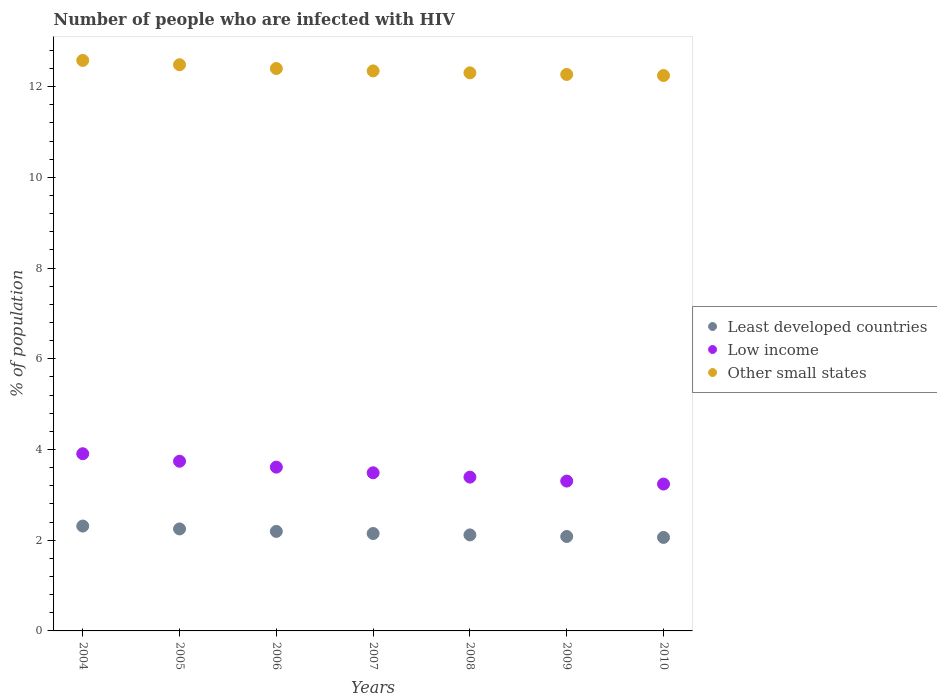How many different coloured dotlines are there?
Provide a succinct answer. 3. Is the number of dotlines equal to the number of legend labels?
Give a very brief answer. Yes. What is the percentage of HIV infected population in in Low income in 2008?
Your answer should be very brief. 3.39. Across all years, what is the maximum percentage of HIV infected population in in Other small states?
Provide a short and direct response. 12.58. Across all years, what is the minimum percentage of HIV infected population in in Other small states?
Offer a terse response. 12.24. In which year was the percentage of HIV infected population in in Least developed countries maximum?
Your answer should be compact. 2004. In which year was the percentage of HIV infected population in in Least developed countries minimum?
Provide a succinct answer. 2010. What is the total percentage of HIV infected population in in Low income in the graph?
Provide a succinct answer. 24.68. What is the difference between the percentage of HIV infected population in in Least developed countries in 2004 and that in 2008?
Offer a terse response. 0.2. What is the difference between the percentage of HIV infected population in in Other small states in 2005 and the percentage of HIV infected population in in Low income in 2010?
Your answer should be very brief. 9.24. What is the average percentage of HIV infected population in in Low income per year?
Your response must be concise. 3.53. In the year 2009, what is the difference between the percentage of HIV infected population in in Low income and percentage of HIV infected population in in Other small states?
Provide a succinct answer. -8.96. In how many years, is the percentage of HIV infected population in in Least developed countries greater than 2.4 %?
Ensure brevity in your answer.  0. What is the ratio of the percentage of HIV infected population in in Least developed countries in 2004 to that in 2009?
Offer a very short reply. 1.11. Is the percentage of HIV infected population in in Other small states in 2005 less than that in 2006?
Offer a very short reply. No. What is the difference between the highest and the second highest percentage of HIV infected population in in Least developed countries?
Offer a terse response. 0.06. What is the difference between the highest and the lowest percentage of HIV infected population in in Other small states?
Your response must be concise. 0.33. Does the percentage of HIV infected population in in Low income monotonically increase over the years?
Your answer should be very brief. No. Is the percentage of HIV infected population in in Other small states strictly less than the percentage of HIV infected population in in Least developed countries over the years?
Ensure brevity in your answer.  No. How many years are there in the graph?
Your answer should be very brief. 7. What is the difference between two consecutive major ticks on the Y-axis?
Your answer should be compact. 2. Are the values on the major ticks of Y-axis written in scientific E-notation?
Ensure brevity in your answer.  No. Where does the legend appear in the graph?
Keep it short and to the point. Center right. How many legend labels are there?
Provide a short and direct response. 3. What is the title of the graph?
Offer a terse response. Number of people who are infected with HIV. Does "Cote d'Ivoire" appear as one of the legend labels in the graph?
Your answer should be compact. No. What is the label or title of the X-axis?
Provide a succinct answer. Years. What is the label or title of the Y-axis?
Ensure brevity in your answer.  % of population. What is the % of population of Least developed countries in 2004?
Offer a very short reply. 2.31. What is the % of population of Low income in 2004?
Give a very brief answer. 3.91. What is the % of population of Other small states in 2004?
Your response must be concise. 12.58. What is the % of population in Least developed countries in 2005?
Your answer should be compact. 2.25. What is the % of population of Low income in 2005?
Your answer should be compact. 3.74. What is the % of population in Other small states in 2005?
Your answer should be very brief. 12.48. What is the % of population of Least developed countries in 2006?
Keep it short and to the point. 2.19. What is the % of population in Low income in 2006?
Your answer should be compact. 3.61. What is the % of population in Other small states in 2006?
Provide a succinct answer. 12.4. What is the % of population in Least developed countries in 2007?
Offer a terse response. 2.15. What is the % of population in Low income in 2007?
Keep it short and to the point. 3.49. What is the % of population of Other small states in 2007?
Provide a short and direct response. 12.35. What is the % of population of Least developed countries in 2008?
Your answer should be compact. 2.12. What is the % of population of Low income in 2008?
Provide a short and direct response. 3.39. What is the % of population in Other small states in 2008?
Your response must be concise. 12.3. What is the % of population in Least developed countries in 2009?
Provide a short and direct response. 2.08. What is the % of population of Low income in 2009?
Make the answer very short. 3.3. What is the % of population in Other small states in 2009?
Offer a very short reply. 12.27. What is the % of population in Least developed countries in 2010?
Provide a short and direct response. 2.06. What is the % of population of Low income in 2010?
Ensure brevity in your answer.  3.24. What is the % of population in Other small states in 2010?
Provide a succinct answer. 12.24. Across all years, what is the maximum % of population in Least developed countries?
Your answer should be very brief. 2.31. Across all years, what is the maximum % of population in Low income?
Your response must be concise. 3.91. Across all years, what is the maximum % of population of Other small states?
Offer a very short reply. 12.58. Across all years, what is the minimum % of population in Least developed countries?
Offer a very short reply. 2.06. Across all years, what is the minimum % of population in Low income?
Your answer should be very brief. 3.24. Across all years, what is the minimum % of population of Other small states?
Ensure brevity in your answer.  12.24. What is the total % of population of Least developed countries in the graph?
Your answer should be compact. 15.16. What is the total % of population in Low income in the graph?
Give a very brief answer. 24.68. What is the total % of population of Other small states in the graph?
Provide a succinct answer. 86.62. What is the difference between the % of population of Least developed countries in 2004 and that in 2005?
Give a very brief answer. 0.06. What is the difference between the % of population in Low income in 2004 and that in 2005?
Offer a very short reply. 0.17. What is the difference between the % of population of Other small states in 2004 and that in 2005?
Offer a terse response. 0.09. What is the difference between the % of population in Least developed countries in 2004 and that in 2006?
Provide a short and direct response. 0.12. What is the difference between the % of population of Low income in 2004 and that in 2006?
Give a very brief answer. 0.3. What is the difference between the % of population of Other small states in 2004 and that in 2006?
Provide a succinct answer. 0.18. What is the difference between the % of population in Least developed countries in 2004 and that in 2007?
Offer a very short reply. 0.16. What is the difference between the % of population of Low income in 2004 and that in 2007?
Your answer should be compact. 0.42. What is the difference between the % of population of Other small states in 2004 and that in 2007?
Provide a succinct answer. 0.23. What is the difference between the % of population in Least developed countries in 2004 and that in 2008?
Make the answer very short. 0.2. What is the difference between the % of population in Low income in 2004 and that in 2008?
Your answer should be very brief. 0.52. What is the difference between the % of population of Other small states in 2004 and that in 2008?
Offer a very short reply. 0.27. What is the difference between the % of population of Least developed countries in 2004 and that in 2009?
Ensure brevity in your answer.  0.23. What is the difference between the % of population of Low income in 2004 and that in 2009?
Provide a succinct answer. 0.6. What is the difference between the % of population of Other small states in 2004 and that in 2009?
Ensure brevity in your answer.  0.31. What is the difference between the % of population in Least developed countries in 2004 and that in 2010?
Ensure brevity in your answer.  0.25. What is the difference between the % of population in Low income in 2004 and that in 2010?
Offer a terse response. 0.67. What is the difference between the % of population of Other small states in 2004 and that in 2010?
Keep it short and to the point. 0.33. What is the difference between the % of population in Least developed countries in 2005 and that in 2006?
Provide a succinct answer. 0.05. What is the difference between the % of population in Low income in 2005 and that in 2006?
Your answer should be compact. 0.13. What is the difference between the % of population in Other small states in 2005 and that in 2006?
Your answer should be very brief. 0.08. What is the difference between the % of population of Least developed countries in 2005 and that in 2007?
Your response must be concise. 0.1. What is the difference between the % of population of Low income in 2005 and that in 2007?
Keep it short and to the point. 0.25. What is the difference between the % of population of Other small states in 2005 and that in 2007?
Offer a terse response. 0.14. What is the difference between the % of population in Least developed countries in 2005 and that in 2008?
Your response must be concise. 0.13. What is the difference between the % of population in Other small states in 2005 and that in 2008?
Provide a succinct answer. 0.18. What is the difference between the % of population of Least developed countries in 2005 and that in 2009?
Your answer should be compact. 0.17. What is the difference between the % of population in Low income in 2005 and that in 2009?
Your answer should be very brief. 0.44. What is the difference between the % of population in Other small states in 2005 and that in 2009?
Make the answer very short. 0.21. What is the difference between the % of population in Least developed countries in 2005 and that in 2010?
Ensure brevity in your answer.  0.19. What is the difference between the % of population of Low income in 2005 and that in 2010?
Your response must be concise. 0.5. What is the difference between the % of population of Other small states in 2005 and that in 2010?
Your response must be concise. 0.24. What is the difference between the % of population of Least developed countries in 2006 and that in 2007?
Ensure brevity in your answer.  0.05. What is the difference between the % of population of Low income in 2006 and that in 2007?
Your answer should be very brief. 0.12. What is the difference between the % of population in Other small states in 2006 and that in 2007?
Give a very brief answer. 0.05. What is the difference between the % of population in Least developed countries in 2006 and that in 2008?
Provide a short and direct response. 0.08. What is the difference between the % of population in Low income in 2006 and that in 2008?
Keep it short and to the point. 0.22. What is the difference between the % of population of Other small states in 2006 and that in 2008?
Your answer should be compact. 0.09. What is the difference between the % of population in Least developed countries in 2006 and that in 2009?
Provide a succinct answer. 0.11. What is the difference between the % of population in Low income in 2006 and that in 2009?
Offer a very short reply. 0.31. What is the difference between the % of population of Other small states in 2006 and that in 2009?
Provide a short and direct response. 0.13. What is the difference between the % of population of Least developed countries in 2006 and that in 2010?
Give a very brief answer. 0.13. What is the difference between the % of population in Low income in 2006 and that in 2010?
Your response must be concise. 0.37. What is the difference between the % of population in Other small states in 2006 and that in 2010?
Keep it short and to the point. 0.15. What is the difference between the % of population in Least developed countries in 2007 and that in 2008?
Offer a very short reply. 0.03. What is the difference between the % of population in Low income in 2007 and that in 2008?
Ensure brevity in your answer.  0.1. What is the difference between the % of population in Other small states in 2007 and that in 2008?
Make the answer very short. 0.04. What is the difference between the % of population of Least developed countries in 2007 and that in 2009?
Keep it short and to the point. 0.07. What is the difference between the % of population in Low income in 2007 and that in 2009?
Give a very brief answer. 0.18. What is the difference between the % of population of Other small states in 2007 and that in 2009?
Ensure brevity in your answer.  0.08. What is the difference between the % of population of Least developed countries in 2007 and that in 2010?
Give a very brief answer. 0.09. What is the difference between the % of population in Low income in 2007 and that in 2010?
Give a very brief answer. 0.25. What is the difference between the % of population of Other small states in 2007 and that in 2010?
Ensure brevity in your answer.  0.1. What is the difference between the % of population in Least developed countries in 2008 and that in 2009?
Your response must be concise. 0.03. What is the difference between the % of population in Low income in 2008 and that in 2009?
Provide a short and direct response. 0.09. What is the difference between the % of population in Other small states in 2008 and that in 2009?
Your response must be concise. 0.04. What is the difference between the % of population in Least developed countries in 2008 and that in 2010?
Your answer should be compact. 0.06. What is the difference between the % of population of Low income in 2008 and that in 2010?
Ensure brevity in your answer.  0.15. What is the difference between the % of population in Other small states in 2008 and that in 2010?
Keep it short and to the point. 0.06. What is the difference between the % of population in Least developed countries in 2009 and that in 2010?
Offer a terse response. 0.02. What is the difference between the % of population of Low income in 2009 and that in 2010?
Offer a very short reply. 0.07. What is the difference between the % of population of Other small states in 2009 and that in 2010?
Provide a succinct answer. 0.02. What is the difference between the % of population in Least developed countries in 2004 and the % of population in Low income in 2005?
Your answer should be very brief. -1.43. What is the difference between the % of population of Least developed countries in 2004 and the % of population of Other small states in 2005?
Provide a succinct answer. -10.17. What is the difference between the % of population in Low income in 2004 and the % of population in Other small states in 2005?
Make the answer very short. -8.58. What is the difference between the % of population of Least developed countries in 2004 and the % of population of Low income in 2006?
Make the answer very short. -1.3. What is the difference between the % of population in Least developed countries in 2004 and the % of population in Other small states in 2006?
Ensure brevity in your answer.  -10.09. What is the difference between the % of population in Low income in 2004 and the % of population in Other small states in 2006?
Ensure brevity in your answer.  -8.49. What is the difference between the % of population of Least developed countries in 2004 and the % of population of Low income in 2007?
Provide a succinct answer. -1.17. What is the difference between the % of population of Least developed countries in 2004 and the % of population of Other small states in 2007?
Provide a succinct answer. -10.03. What is the difference between the % of population of Low income in 2004 and the % of population of Other small states in 2007?
Keep it short and to the point. -8.44. What is the difference between the % of population of Least developed countries in 2004 and the % of population of Low income in 2008?
Make the answer very short. -1.08. What is the difference between the % of population of Least developed countries in 2004 and the % of population of Other small states in 2008?
Keep it short and to the point. -9.99. What is the difference between the % of population of Low income in 2004 and the % of population of Other small states in 2008?
Your response must be concise. -8.4. What is the difference between the % of population of Least developed countries in 2004 and the % of population of Low income in 2009?
Provide a short and direct response. -0.99. What is the difference between the % of population in Least developed countries in 2004 and the % of population in Other small states in 2009?
Provide a succinct answer. -9.96. What is the difference between the % of population in Low income in 2004 and the % of population in Other small states in 2009?
Offer a terse response. -8.36. What is the difference between the % of population in Least developed countries in 2004 and the % of population in Low income in 2010?
Provide a short and direct response. -0.93. What is the difference between the % of population in Least developed countries in 2004 and the % of population in Other small states in 2010?
Offer a terse response. -9.93. What is the difference between the % of population of Low income in 2004 and the % of population of Other small states in 2010?
Your answer should be very brief. -8.34. What is the difference between the % of population in Least developed countries in 2005 and the % of population in Low income in 2006?
Give a very brief answer. -1.36. What is the difference between the % of population of Least developed countries in 2005 and the % of population of Other small states in 2006?
Ensure brevity in your answer.  -10.15. What is the difference between the % of population in Low income in 2005 and the % of population in Other small states in 2006?
Your response must be concise. -8.66. What is the difference between the % of population in Least developed countries in 2005 and the % of population in Low income in 2007?
Offer a terse response. -1.24. What is the difference between the % of population of Least developed countries in 2005 and the % of population of Other small states in 2007?
Offer a terse response. -10.1. What is the difference between the % of population of Low income in 2005 and the % of population of Other small states in 2007?
Provide a short and direct response. -8.6. What is the difference between the % of population of Least developed countries in 2005 and the % of population of Low income in 2008?
Ensure brevity in your answer.  -1.14. What is the difference between the % of population of Least developed countries in 2005 and the % of population of Other small states in 2008?
Give a very brief answer. -10.05. What is the difference between the % of population in Low income in 2005 and the % of population in Other small states in 2008?
Give a very brief answer. -8.56. What is the difference between the % of population in Least developed countries in 2005 and the % of population in Low income in 2009?
Give a very brief answer. -1.05. What is the difference between the % of population in Least developed countries in 2005 and the % of population in Other small states in 2009?
Keep it short and to the point. -10.02. What is the difference between the % of population in Low income in 2005 and the % of population in Other small states in 2009?
Provide a succinct answer. -8.53. What is the difference between the % of population in Least developed countries in 2005 and the % of population in Low income in 2010?
Offer a terse response. -0.99. What is the difference between the % of population in Least developed countries in 2005 and the % of population in Other small states in 2010?
Your answer should be very brief. -10. What is the difference between the % of population in Low income in 2005 and the % of population in Other small states in 2010?
Your answer should be very brief. -8.5. What is the difference between the % of population in Least developed countries in 2006 and the % of population in Low income in 2007?
Give a very brief answer. -1.29. What is the difference between the % of population of Least developed countries in 2006 and the % of population of Other small states in 2007?
Your response must be concise. -10.15. What is the difference between the % of population in Low income in 2006 and the % of population in Other small states in 2007?
Give a very brief answer. -8.73. What is the difference between the % of population of Least developed countries in 2006 and the % of population of Low income in 2008?
Offer a terse response. -1.2. What is the difference between the % of population of Least developed countries in 2006 and the % of population of Other small states in 2008?
Keep it short and to the point. -10.11. What is the difference between the % of population in Low income in 2006 and the % of population in Other small states in 2008?
Your answer should be compact. -8.69. What is the difference between the % of population in Least developed countries in 2006 and the % of population in Low income in 2009?
Ensure brevity in your answer.  -1.11. What is the difference between the % of population in Least developed countries in 2006 and the % of population in Other small states in 2009?
Provide a short and direct response. -10.07. What is the difference between the % of population of Low income in 2006 and the % of population of Other small states in 2009?
Give a very brief answer. -8.66. What is the difference between the % of population in Least developed countries in 2006 and the % of population in Low income in 2010?
Make the answer very short. -1.04. What is the difference between the % of population in Least developed countries in 2006 and the % of population in Other small states in 2010?
Offer a terse response. -10.05. What is the difference between the % of population of Low income in 2006 and the % of population of Other small states in 2010?
Provide a succinct answer. -8.63. What is the difference between the % of population of Least developed countries in 2007 and the % of population of Low income in 2008?
Provide a succinct answer. -1.24. What is the difference between the % of population in Least developed countries in 2007 and the % of population in Other small states in 2008?
Your response must be concise. -10.16. What is the difference between the % of population in Low income in 2007 and the % of population in Other small states in 2008?
Your response must be concise. -8.82. What is the difference between the % of population in Least developed countries in 2007 and the % of population in Low income in 2009?
Make the answer very short. -1.16. What is the difference between the % of population in Least developed countries in 2007 and the % of population in Other small states in 2009?
Offer a very short reply. -10.12. What is the difference between the % of population of Low income in 2007 and the % of population of Other small states in 2009?
Offer a terse response. -8.78. What is the difference between the % of population of Least developed countries in 2007 and the % of population of Low income in 2010?
Make the answer very short. -1.09. What is the difference between the % of population in Least developed countries in 2007 and the % of population in Other small states in 2010?
Your answer should be very brief. -10.1. What is the difference between the % of population of Low income in 2007 and the % of population of Other small states in 2010?
Make the answer very short. -8.76. What is the difference between the % of population of Least developed countries in 2008 and the % of population of Low income in 2009?
Offer a terse response. -1.19. What is the difference between the % of population in Least developed countries in 2008 and the % of population in Other small states in 2009?
Your answer should be compact. -10.15. What is the difference between the % of population of Low income in 2008 and the % of population of Other small states in 2009?
Your answer should be very brief. -8.88. What is the difference between the % of population in Least developed countries in 2008 and the % of population in Low income in 2010?
Ensure brevity in your answer.  -1.12. What is the difference between the % of population of Least developed countries in 2008 and the % of population of Other small states in 2010?
Provide a short and direct response. -10.13. What is the difference between the % of population in Low income in 2008 and the % of population in Other small states in 2010?
Provide a succinct answer. -8.85. What is the difference between the % of population in Least developed countries in 2009 and the % of population in Low income in 2010?
Your response must be concise. -1.16. What is the difference between the % of population of Least developed countries in 2009 and the % of population of Other small states in 2010?
Offer a very short reply. -10.16. What is the difference between the % of population of Low income in 2009 and the % of population of Other small states in 2010?
Make the answer very short. -8.94. What is the average % of population of Least developed countries per year?
Offer a very short reply. 2.17. What is the average % of population of Low income per year?
Offer a terse response. 3.53. What is the average % of population in Other small states per year?
Offer a very short reply. 12.37. In the year 2004, what is the difference between the % of population of Least developed countries and % of population of Low income?
Offer a terse response. -1.59. In the year 2004, what is the difference between the % of population in Least developed countries and % of population in Other small states?
Ensure brevity in your answer.  -10.26. In the year 2004, what is the difference between the % of population of Low income and % of population of Other small states?
Make the answer very short. -8.67. In the year 2005, what is the difference between the % of population in Least developed countries and % of population in Low income?
Give a very brief answer. -1.49. In the year 2005, what is the difference between the % of population of Least developed countries and % of population of Other small states?
Your answer should be very brief. -10.23. In the year 2005, what is the difference between the % of population in Low income and % of population in Other small states?
Offer a very short reply. -8.74. In the year 2006, what is the difference between the % of population of Least developed countries and % of population of Low income?
Offer a terse response. -1.42. In the year 2006, what is the difference between the % of population in Least developed countries and % of population in Other small states?
Make the answer very short. -10.2. In the year 2006, what is the difference between the % of population of Low income and % of population of Other small states?
Provide a succinct answer. -8.79. In the year 2007, what is the difference between the % of population of Least developed countries and % of population of Low income?
Ensure brevity in your answer.  -1.34. In the year 2007, what is the difference between the % of population in Least developed countries and % of population in Other small states?
Give a very brief answer. -10.2. In the year 2007, what is the difference between the % of population of Low income and % of population of Other small states?
Your response must be concise. -8.86. In the year 2008, what is the difference between the % of population in Least developed countries and % of population in Low income?
Ensure brevity in your answer.  -1.27. In the year 2008, what is the difference between the % of population in Least developed countries and % of population in Other small states?
Your response must be concise. -10.19. In the year 2008, what is the difference between the % of population of Low income and % of population of Other small states?
Provide a short and direct response. -8.91. In the year 2009, what is the difference between the % of population of Least developed countries and % of population of Low income?
Offer a very short reply. -1.22. In the year 2009, what is the difference between the % of population of Least developed countries and % of population of Other small states?
Keep it short and to the point. -10.19. In the year 2009, what is the difference between the % of population of Low income and % of population of Other small states?
Offer a terse response. -8.96. In the year 2010, what is the difference between the % of population in Least developed countries and % of population in Low income?
Give a very brief answer. -1.18. In the year 2010, what is the difference between the % of population of Least developed countries and % of population of Other small states?
Make the answer very short. -10.18. In the year 2010, what is the difference between the % of population of Low income and % of population of Other small states?
Offer a terse response. -9.01. What is the ratio of the % of population in Least developed countries in 2004 to that in 2005?
Your response must be concise. 1.03. What is the ratio of the % of population of Low income in 2004 to that in 2005?
Provide a short and direct response. 1.04. What is the ratio of the % of population of Other small states in 2004 to that in 2005?
Provide a short and direct response. 1.01. What is the ratio of the % of population of Least developed countries in 2004 to that in 2006?
Give a very brief answer. 1.05. What is the ratio of the % of population of Low income in 2004 to that in 2006?
Make the answer very short. 1.08. What is the ratio of the % of population in Other small states in 2004 to that in 2006?
Ensure brevity in your answer.  1.01. What is the ratio of the % of population in Least developed countries in 2004 to that in 2007?
Provide a succinct answer. 1.08. What is the ratio of the % of population of Low income in 2004 to that in 2007?
Your answer should be compact. 1.12. What is the ratio of the % of population in Other small states in 2004 to that in 2007?
Your answer should be compact. 1.02. What is the ratio of the % of population in Least developed countries in 2004 to that in 2008?
Your answer should be very brief. 1.09. What is the ratio of the % of population in Low income in 2004 to that in 2008?
Offer a very short reply. 1.15. What is the ratio of the % of population of Other small states in 2004 to that in 2008?
Keep it short and to the point. 1.02. What is the ratio of the % of population in Least developed countries in 2004 to that in 2009?
Offer a very short reply. 1.11. What is the ratio of the % of population in Low income in 2004 to that in 2009?
Your response must be concise. 1.18. What is the ratio of the % of population in Other small states in 2004 to that in 2009?
Provide a short and direct response. 1.03. What is the ratio of the % of population of Least developed countries in 2004 to that in 2010?
Provide a short and direct response. 1.12. What is the ratio of the % of population in Low income in 2004 to that in 2010?
Give a very brief answer. 1.21. What is the ratio of the % of population of Other small states in 2004 to that in 2010?
Offer a very short reply. 1.03. What is the ratio of the % of population of Least developed countries in 2005 to that in 2006?
Ensure brevity in your answer.  1.02. What is the ratio of the % of population in Low income in 2005 to that in 2006?
Keep it short and to the point. 1.04. What is the ratio of the % of population of Other small states in 2005 to that in 2006?
Make the answer very short. 1.01. What is the ratio of the % of population of Least developed countries in 2005 to that in 2007?
Provide a short and direct response. 1.05. What is the ratio of the % of population of Low income in 2005 to that in 2007?
Offer a very short reply. 1.07. What is the ratio of the % of population in Other small states in 2005 to that in 2007?
Make the answer very short. 1.01. What is the ratio of the % of population in Least developed countries in 2005 to that in 2008?
Your answer should be compact. 1.06. What is the ratio of the % of population of Low income in 2005 to that in 2008?
Keep it short and to the point. 1.1. What is the ratio of the % of population of Other small states in 2005 to that in 2008?
Your response must be concise. 1.01. What is the ratio of the % of population of Least developed countries in 2005 to that in 2009?
Provide a short and direct response. 1.08. What is the ratio of the % of population of Low income in 2005 to that in 2009?
Give a very brief answer. 1.13. What is the ratio of the % of population in Other small states in 2005 to that in 2009?
Ensure brevity in your answer.  1.02. What is the ratio of the % of population in Least developed countries in 2005 to that in 2010?
Make the answer very short. 1.09. What is the ratio of the % of population of Low income in 2005 to that in 2010?
Your answer should be compact. 1.16. What is the ratio of the % of population in Other small states in 2005 to that in 2010?
Your answer should be compact. 1.02. What is the ratio of the % of population of Least developed countries in 2006 to that in 2007?
Your answer should be compact. 1.02. What is the ratio of the % of population of Low income in 2006 to that in 2007?
Ensure brevity in your answer.  1.04. What is the ratio of the % of population of Other small states in 2006 to that in 2007?
Ensure brevity in your answer.  1. What is the ratio of the % of population of Least developed countries in 2006 to that in 2008?
Your response must be concise. 1.04. What is the ratio of the % of population of Low income in 2006 to that in 2008?
Your answer should be compact. 1.06. What is the ratio of the % of population in Other small states in 2006 to that in 2008?
Your response must be concise. 1.01. What is the ratio of the % of population in Least developed countries in 2006 to that in 2009?
Give a very brief answer. 1.05. What is the ratio of the % of population of Low income in 2006 to that in 2009?
Provide a short and direct response. 1.09. What is the ratio of the % of population in Other small states in 2006 to that in 2009?
Ensure brevity in your answer.  1.01. What is the ratio of the % of population of Least developed countries in 2006 to that in 2010?
Keep it short and to the point. 1.06. What is the ratio of the % of population in Low income in 2006 to that in 2010?
Make the answer very short. 1.12. What is the ratio of the % of population in Other small states in 2006 to that in 2010?
Your answer should be very brief. 1.01. What is the ratio of the % of population in Least developed countries in 2007 to that in 2008?
Provide a succinct answer. 1.01. What is the ratio of the % of population of Low income in 2007 to that in 2008?
Your response must be concise. 1.03. What is the ratio of the % of population in Least developed countries in 2007 to that in 2009?
Offer a terse response. 1.03. What is the ratio of the % of population in Low income in 2007 to that in 2009?
Your answer should be compact. 1.06. What is the ratio of the % of population in Other small states in 2007 to that in 2009?
Your answer should be very brief. 1.01. What is the ratio of the % of population of Least developed countries in 2007 to that in 2010?
Ensure brevity in your answer.  1.04. What is the ratio of the % of population of Low income in 2007 to that in 2010?
Offer a terse response. 1.08. What is the ratio of the % of population in Other small states in 2007 to that in 2010?
Your answer should be very brief. 1.01. What is the ratio of the % of population in Least developed countries in 2008 to that in 2009?
Make the answer very short. 1.02. What is the ratio of the % of population of Low income in 2008 to that in 2009?
Ensure brevity in your answer.  1.03. What is the ratio of the % of population of Least developed countries in 2008 to that in 2010?
Ensure brevity in your answer.  1.03. What is the ratio of the % of population in Low income in 2008 to that in 2010?
Make the answer very short. 1.05. What is the ratio of the % of population of Least developed countries in 2009 to that in 2010?
Your answer should be very brief. 1.01. What is the ratio of the % of population of Low income in 2009 to that in 2010?
Your answer should be compact. 1.02. What is the difference between the highest and the second highest % of population of Least developed countries?
Your answer should be compact. 0.06. What is the difference between the highest and the second highest % of population in Low income?
Offer a terse response. 0.17. What is the difference between the highest and the second highest % of population in Other small states?
Your answer should be very brief. 0.09. What is the difference between the highest and the lowest % of population of Least developed countries?
Give a very brief answer. 0.25. What is the difference between the highest and the lowest % of population of Low income?
Offer a terse response. 0.67. What is the difference between the highest and the lowest % of population in Other small states?
Make the answer very short. 0.33. 